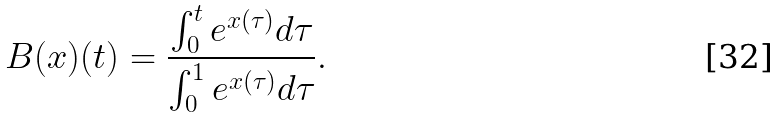Convert formula to latex. <formula><loc_0><loc_0><loc_500><loc_500>B ( x ) ( t ) = \frac { \int _ { 0 } ^ { t } e ^ { x ( \tau ) } d \tau } { \int _ { 0 } ^ { 1 } e ^ { x ( \tau ) } d \tau } .</formula> 